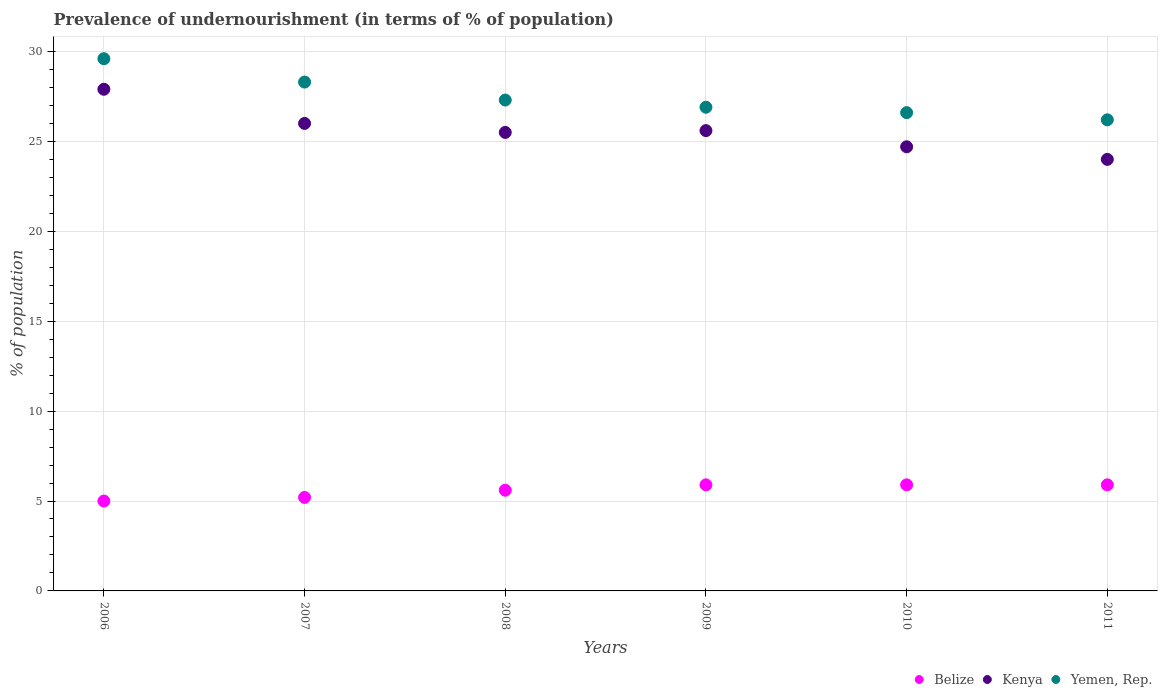Is the number of dotlines equal to the number of legend labels?
Offer a very short reply. Yes. Across all years, what is the maximum percentage of undernourished population in Yemen, Rep.?
Your answer should be very brief. 29.6. In which year was the percentage of undernourished population in Kenya maximum?
Your answer should be compact. 2006. In which year was the percentage of undernourished population in Belize minimum?
Offer a very short reply. 2006. What is the total percentage of undernourished population in Belize in the graph?
Your response must be concise. 33.5. What is the difference between the percentage of undernourished population in Yemen, Rep. in 2008 and the percentage of undernourished population in Belize in 2009?
Make the answer very short. 21.4. What is the average percentage of undernourished population in Yemen, Rep. per year?
Give a very brief answer. 27.48. In the year 2008, what is the difference between the percentage of undernourished population in Kenya and percentage of undernourished population in Yemen, Rep.?
Your answer should be very brief. -1.8. What is the ratio of the percentage of undernourished population in Yemen, Rep. in 2008 to that in 2011?
Ensure brevity in your answer.  1.04. What is the difference between the highest and the second highest percentage of undernourished population in Kenya?
Give a very brief answer. 1.9. What is the difference between the highest and the lowest percentage of undernourished population in Belize?
Your response must be concise. 0.9. How many dotlines are there?
Offer a terse response. 3. How many years are there in the graph?
Provide a short and direct response. 6. What is the difference between two consecutive major ticks on the Y-axis?
Offer a terse response. 5. Does the graph contain any zero values?
Offer a very short reply. No. Does the graph contain grids?
Offer a terse response. Yes. Where does the legend appear in the graph?
Provide a succinct answer. Bottom right. How many legend labels are there?
Make the answer very short. 3. How are the legend labels stacked?
Make the answer very short. Horizontal. What is the title of the graph?
Your answer should be very brief. Prevalence of undernourishment (in terms of % of population). What is the label or title of the Y-axis?
Provide a short and direct response. % of population. What is the % of population of Kenya in 2006?
Make the answer very short. 27.9. What is the % of population of Yemen, Rep. in 2006?
Provide a short and direct response. 29.6. What is the % of population of Kenya in 2007?
Make the answer very short. 26. What is the % of population in Yemen, Rep. in 2007?
Give a very brief answer. 28.3. What is the % of population of Kenya in 2008?
Offer a terse response. 25.5. What is the % of population in Yemen, Rep. in 2008?
Ensure brevity in your answer.  27.3. What is the % of population of Kenya in 2009?
Keep it short and to the point. 25.6. What is the % of population in Yemen, Rep. in 2009?
Your answer should be compact. 26.9. What is the % of population of Belize in 2010?
Your answer should be very brief. 5.9. What is the % of population of Kenya in 2010?
Your answer should be compact. 24.7. What is the % of population of Yemen, Rep. in 2010?
Make the answer very short. 26.6. What is the % of population in Belize in 2011?
Your response must be concise. 5.9. What is the % of population in Yemen, Rep. in 2011?
Provide a short and direct response. 26.2. Across all years, what is the maximum % of population of Belize?
Offer a very short reply. 5.9. Across all years, what is the maximum % of population of Kenya?
Your response must be concise. 27.9. Across all years, what is the maximum % of population in Yemen, Rep.?
Offer a terse response. 29.6. Across all years, what is the minimum % of population in Kenya?
Offer a terse response. 24. Across all years, what is the minimum % of population in Yemen, Rep.?
Give a very brief answer. 26.2. What is the total % of population of Belize in the graph?
Your response must be concise. 33.5. What is the total % of population in Kenya in the graph?
Provide a succinct answer. 153.7. What is the total % of population in Yemen, Rep. in the graph?
Ensure brevity in your answer.  164.9. What is the difference between the % of population of Belize in 2006 and that in 2007?
Make the answer very short. -0.2. What is the difference between the % of population of Kenya in 2006 and that in 2007?
Your answer should be compact. 1.9. What is the difference between the % of population of Yemen, Rep. in 2006 and that in 2007?
Ensure brevity in your answer.  1.3. What is the difference between the % of population in Belize in 2006 and that in 2008?
Offer a terse response. -0.6. What is the difference between the % of population in Kenya in 2006 and that in 2008?
Make the answer very short. 2.4. What is the difference between the % of population in Belize in 2006 and that in 2009?
Keep it short and to the point. -0.9. What is the difference between the % of population of Kenya in 2006 and that in 2009?
Offer a terse response. 2.3. What is the difference between the % of population in Yemen, Rep. in 2006 and that in 2009?
Make the answer very short. 2.7. What is the difference between the % of population in Belize in 2006 and that in 2010?
Ensure brevity in your answer.  -0.9. What is the difference between the % of population in Kenya in 2006 and that in 2010?
Provide a succinct answer. 3.2. What is the difference between the % of population of Belize in 2006 and that in 2011?
Offer a terse response. -0.9. What is the difference between the % of population in Yemen, Rep. in 2006 and that in 2011?
Your answer should be very brief. 3.4. What is the difference between the % of population in Kenya in 2007 and that in 2008?
Offer a very short reply. 0.5. What is the difference between the % of population in Yemen, Rep. in 2007 and that in 2008?
Offer a very short reply. 1. What is the difference between the % of population in Belize in 2007 and that in 2009?
Offer a very short reply. -0.7. What is the difference between the % of population in Kenya in 2007 and that in 2009?
Provide a succinct answer. 0.4. What is the difference between the % of population of Yemen, Rep. in 2007 and that in 2009?
Provide a short and direct response. 1.4. What is the difference between the % of population of Belize in 2007 and that in 2010?
Offer a terse response. -0.7. What is the difference between the % of population in Kenya in 2007 and that in 2010?
Keep it short and to the point. 1.3. What is the difference between the % of population of Kenya in 2007 and that in 2011?
Ensure brevity in your answer.  2. What is the difference between the % of population in Yemen, Rep. in 2007 and that in 2011?
Your answer should be compact. 2.1. What is the difference between the % of population in Belize in 2008 and that in 2009?
Offer a terse response. -0.3. What is the difference between the % of population of Kenya in 2008 and that in 2009?
Keep it short and to the point. -0.1. What is the difference between the % of population of Yemen, Rep. in 2008 and that in 2009?
Ensure brevity in your answer.  0.4. What is the difference between the % of population in Kenya in 2008 and that in 2010?
Your response must be concise. 0.8. What is the difference between the % of population of Yemen, Rep. in 2008 and that in 2010?
Your answer should be very brief. 0.7. What is the difference between the % of population of Belize in 2008 and that in 2011?
Your answer should be compact. -0.3. What is the difference between the % of population of Kenya in 2008 and that in 2011?
Your answer should be very brief. 1.5. What is the difference between the % of population in Yemen, Rep. in 2009 and that in 2010?
Offer a terse response. 0.3. What is the difference between the % of population of Belize in 2009 and that in 2011?
Offer a terse response. 0. What is the difference between the % of population in Kenya in 2009 and that in 2011?
Provide a short and direct response. 1.6. What is the difference between the % of population in Yemen, Rep. in 2009 and that in 2011?
Make the answer very short. 0.7. What is the difference between the % of population in Yemen, Rep. in 2010 and that in 2011?
Offer a terse response. 0.4. What is the difference between the % of population of Belize in 2006 and the % of population of Yemen, Rep. in 2007?
Give a very brief answer. -23.3. What is the difference between the % of population in Belize in 2006 and the % of population in Kenya in 2008?
Offer a terse response. -20.5. What is the difference between the % of population in Belize in 2006 and the % of population in Yemen, Rep. in 2008?
Ensure brevity in your answer.  -22.3. What is the difference between the % of population of Belize in 2006 and the % of population of Kenya in 2009?
Give a very brief answer. -20.6. What is the difference between the % of population of Belize in 2006 and the % of population of Yemen, Rep. in 2009?
Your response must be concise. -21.9. What is the difference between the % of population in Belize in 2006 and the % of population in Kenya in 2010?
Offer a terse response. -19.7. What is the difference between the % of population in Belize in 2006 and the % of population in Yemen, Rep. in 2010?
Give a very brief answer. -21.6. What is the difference between the % of population of Kenya in 2006 and the % of population of Yemen, Rep. in 2010?
Make the answer very short. 1.3. What is the difference between the % of population in Belize in 2006 and the % of population in Yemen, Rep. in 2011?
Ensure brevity in your answer.  -21.2. What is the difference between the % of population in Belize in 2007 and the % of population in Kenya in 2008?
Make the answer very short. -20.3. What is the difference between the % of population of Belize in 2007 and the % of population of Yemen, Rep. in 2008?
Your answer should be compact. -22.1. What is the difference between the % of population in Kenya in 2007 and the % of population in Yemen, Rep. in 2008?
Give a very brief answer. -1.3. What is the difference between the % of population in Belize in 2007 and the % of population in Kenya in 2009?
Ensure brevity in your answer.  -20.4. What is the difference between the % of population in Belize in 2007 and the % of population in Yemen, Rep. in 2009?
Offer a terse response. -21.7. What is the difference between the % of population in Belize in 2007 and the % of population in Kenya in 2010?
Offer a terse response. -19.5. What is the difference between the % of population of Belize in 2007 and the % of population of Yemen, Rep. in 2010?
Make the answer very short. -21.4. What is the difference between the % of population in Belize in 2007 and the % of population in Kenya in 2011?
Offer a terse response. -18.8. What is the difference between the % of population in Belize in 2007 and the % of population in Yemen, Rep. in 2011?
Your response must be concise. -21. What is the difference between the % of population in Kenya in 2007 and the % of population in Yemen, Rep. in 2011?
Make the answer very short. -0.2. What is the difference between the % of population in Belize in 2008 and the % of population in Yemen, Rep. in 2009?
Provide a short and direct response. -21.3. What is the difference between the % of population in Kenya in 2008 and the % of population in Yemen, Rep. in 2009?
Offer a terse response. -1.4. What is the difference between the % of population of Belize in 2008 and the % of population of Kenya in 2010?
Make the answer very short. -19.1. What is the difference between the % of population of Belize in 2008 and the % of population of Yemen, Rep. in 2010?
Ensure brevity in your answer.  -21. What is the difference between the % of population of Belize in 2008 and the % of population of Kenya in 2011?
Make the answer very short. -18.4. What is the difference between the % of population of Belize in 2008 and the % of population of Yemen, Rep. in 2011?
Your answer should be compact. -20.6. What is the difference between the % of population of Kenya in 2008 and the % of population of Yemen, Rep. in 2011?
Ensure brevity in your answer.  -0.7. What is the difference between the % of population in Belize in 2009 and the % of population in Kenya in 2010?
Offer a very short reply. -18.8. What is the difference between the % of population of Belize in 2009 and the % of population of Yemen, Rep. in 2010?
Offer a very short reply. -20.7. What is the difference between the % of population in Belize in 2009 and the % of population in Kenya in 2011?
Keep it short and to the point. -18.1. What is the difference between the % of population in Belize in 2009 and the % of population in Yemen, Rep. in 2011?
Offer a terse response. -20.3. What is the difference between the % of population of Belize in 2010 and the % of population of Kenya in 2011?
Your answer should be compact. -18.1. What is the difference between the % of population in Belize in 2010 and the % of population in Yemen, Rep. in 2011?
Your answer should be compact. -20.3. What is the average % of population in Belize per year?
Your response must be concise. 5.58. What is the average % of population of Kenya per year?
Ensure brevity in your answer.  25.62. What is the average % of population of Yemen, Rep. per year?
Offer a terse response. 27.48. In the year 2006, what is the difference between the % of population in Belize and % of population in Kenya?
Keep it short and to the point. -22.9. In the year 2006, what is the difference between the % of population in Belize and % of population in Yemen, Rep.?
Your response must be concise. -24.6. In the year 2007, what is the difference between the % of population of Belize and % of population of Kenya?
Give a very brief answer. -20.8. In the year 2007, what is the difference between the % of population in Belize and % of population in Yemen, Rep.?
Provide a short and direct response. -23.1. In the year 2007, what is the difference between the % of population in Kenya and % of population in Yemen, Rep.?
Provide a succinct answer. -2.3. In the year 2008, what is the difference between the % of population in Belize and % of population in Kenya?
Ensure brevity in your answer.  -19.9. In the year 2008, what is the difference between the % of population of Belize and % of population of Yemen, Rep.?
Your answer should be very brief. -21.7. In the year 2008, what is the difference between the % of population in Kenya and % of population in Yemen, Rep.?
Your answer should be very brief. -1.8. In the year 2009, what is the difference between the % of population in Belize and % of population in Kenya?
Give a very brief answer. -19.7. In the year 2009, what is the difference between the % of population of Kenya and % of population of Yemen, Rep.?
Give a very brief answer. -1.3. In the year 2010, what is the difference between the % of population in Belize and % of population in Kenya?
Give a very brief answer. -18.8. In the year 2010, what is the difference between the % of population of Belize and % of population of Yemen, Rep.?
Your answer should be very brief. -20.7. In the year 2010, what is the difference between the % of population of Kenya and % of population of Yemen, Rep.?
Your response must be concise. -1.9. In the year 2011, what is the difference between the % of population of Belize and % of population of Kenya?
Your response must be concise. -18.1. In the year 2011, what is the difference between the % of population in Belize and % of population in Yemen, Rep.?
Your answer should be very brief. -20.3. In the year 2011, what is the difference between the % of population of Kenya and % of population of Yemen, Rep.?
Ensure brevity in your answer.  -2.2. What is the ratio of the % of population of Belize in 2006 to that in 2007?
Ensure brevity in your answer.  0.96. What is the ratio of the % of population of Kenya in 2006 to that in 2007?
Make the answer very short. 1.07. What is the ratio of the % of population of Yemen, Rep. in 2006 to that in 2007?
Provide a short and direct response. 1.05. What is the ratio of the % of population of Belize in 2006 to that in 2008?
Give a very brief answer. 0.89. What is the ratio of the % of population of Kenya in 2006 to that in 2008?
Your answer should be compact. 1.09. What is the ratio of the % of population of Yemen, Rep. in 2006 to that in 2008?
Your answer should be very brief. 1.08. What is the ratio of the % of population of Belize in 2006 to that in 2009?
Give a very brief answer. 0.85. What is the ratio of the % of population in Kenya in 2006 to that in 2009?
Provide a succinct answer. 1.09. What is the ratio of the % of population of Yemen, Rep. in 2006 to that in 2009?
Your answer should be very brief. 1.1. What is the ratio of the % of population in Belize in 2006 to that in 2010?
Your answer should be very brief. 0.85. What is the ratio of the % of population in Kenya in 2006 to that in 2010?
Offer a terse response. 1.13. What is the ratio of the % of population in Yemen, Rep. in 2006 to that in 2010?
Provide a succinct answer. 1.11. What is the ratio of the % of population in Belize in 2006 to that in 2011?
Give a very brief answer. 0.85. What is the ratio of the % of population of Kenya in 2006 to that in 2011?
Offer a very short reply. 1.16. What is the ratio of the % of population of Yemen, Rep. in 2006 to that in 2011?
Make the answer very short. 1.13. What is the ratio of the % of population in Kenya in 2007 to that in 2008?
Keep it short and to the point. 1.02. What is the ratio of the % of population of Yemen, Rep. in 2007 to that in 2008?
Provide a succinct answer. 1.04. What is the ratio of the % of population in Belize in 2007 to that in 2009?
Provide a short and direct response. 0.88. What is the ratio of the % of population in Kenya in 2007 to that in 2009?
Keep it short and to the point. 1.02. What is the ratio of the % of population in Yemen, Rep. in 2007 to that in 2009?
Your response must be concise. 1.05. What is the ratio of the % of population of Belize in 2007 to that in 2010?
Your response must be concise. 0.88. What is the ratio of the % of population of Kenya in 2007 to that in 2010?
Your answer should be very brief. 1.05. What is the ratio of the % of population in Yemen, Rep. in 2007 to that in 2010?
Give a very brief answer. 1.06. What is the ratio of the % of population of Belize in 2007 to that in 2011?
Your response must be concise. 0.88. What is the ratio of the % of population in Yemen, Rep. in 2007 to that in 2011?
Offer a terse response. 1.08. What is the ratio of the % of population of Belize in 2008 to that in 2009?
Ensure brevity in your answer.  0.95. What is the ratio of the % of population of Kenya in 2008 to that in 2009?
Your response must be concise. 1. What is the ratio of the % of population of Yemen, Rep. in 2008 to that in 2009?
Give a very brief answer. 1.01. What is the ratio of the % of population of Belize in 2008 to that in 2010?
Offer a terse response. 0.95. What is the ratio of the % of population in Kenya in 2008 to that in 2010?
Provide a succinct answer. 1.03. What is the ratio of the % of population in Yemen, Rep. in 2008 to that in 2010?
Your answer should be very brief. 1.03. What is the ratio of the % of population in Belize in 2008 to that in 2011?
Keep it short and to the point. 0.95. What is the ratio of the % of population of Kenya in 2008 to that in 2011?
Keep it short and to the point. 1.06. What is the ratio of the % of population in Yemen, Rep. in 2008 to that in 2011?
Give a very brief answer. 1.04. What is the ratio of the % of population of Belize in 2009 to that in 2010?
Make the answer very short. 1. What is the ratio of the % of population of Kenya in 2009 to that in 2010?
Provide a succinct answer. 1.04. What is the ratio of the % of population of Yemen, Rep. in 2009 to that in 2010?
Offer a terse response. 1.01. What is the ratio of the % of population in Belize in 2009 to that in 2011?
Offer a terse response. 1. What is the ratio of the % of population in Kenya in 2009 to that in 2011?
Ensure brevity in your answer.  1.07. What is the ratio of the % of population of Yemen, Rep. in 2009 to that in 2011?
Your response must be concise. 1.03. What is the ratio of the % of population in Kenya in 2010 to that in 2011?
Your answer should be compact. 1.03. What is the ratio of the % of population in Yemen, Rep. in 2010 to that in 2011?
Keep it short and to the point. 1.02. What is the difference between the highest and the second highest % of population of Belize?
Provide a short and direct response. 0. What is the difference between the highest and the second highest % of population of Kenya?
Provide a short and direct response. 1.9. What is the difference between the highest and the second highest % of population of Yemen, Rep.?
Provide a short and direct response. 1.3. What is the difference between the highest and the lowest % of population of Belize?
Provide a succinct answer. 0.9. What is the difference between the highest and the lowest % of population in Kenya?
Your response must be concise. 3.9. What is the difference between the highest and the lowest % of population of Yemen, Rep.?
Your answer should be very brief. 3.4. 